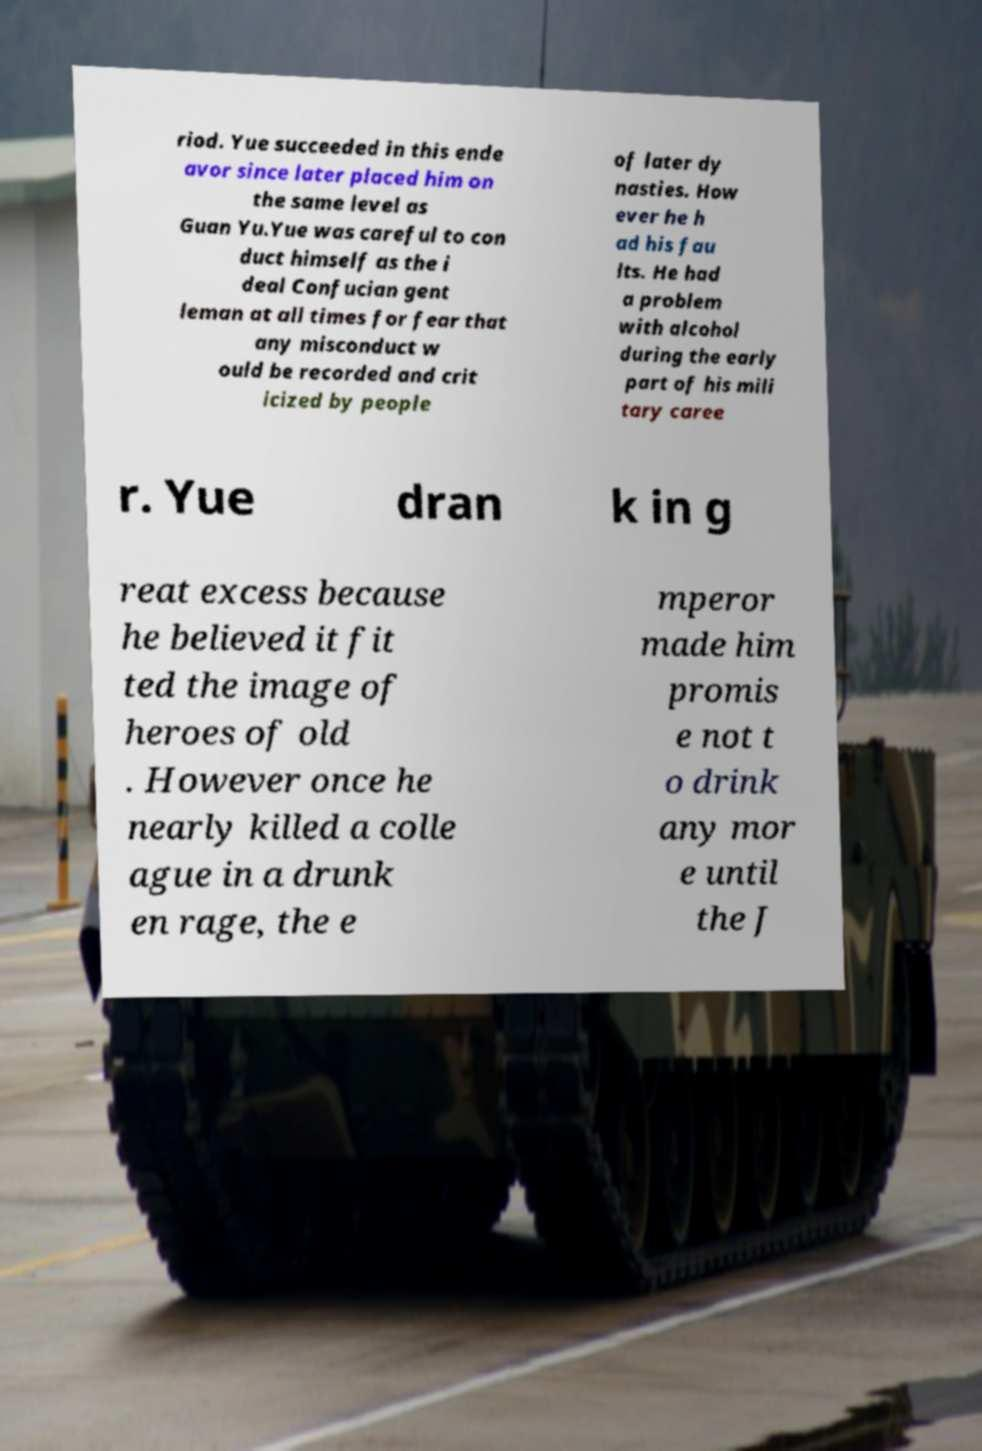Could you assist in decoding the text presented in this image and type it out clearly? riod. Yue succeeded in this ende avor since later placed him on the same level as Guan Yu.Yue was careful to con duct himself as the i deal Confucian gent leman at all times for fear that any misconduct w ould be recorded and crit icized by people of later dy nasties. How ever he h ad his fau lts. He had a problem with alcohol during the early part of his mili tary caree r. Yue dran k in g reat excess because he believed it fit ted the image of heroes of old . However once he nearly killed a colle ague in a drunk en rage, the e mperor made him promis e not t o drink any mor e until the J 